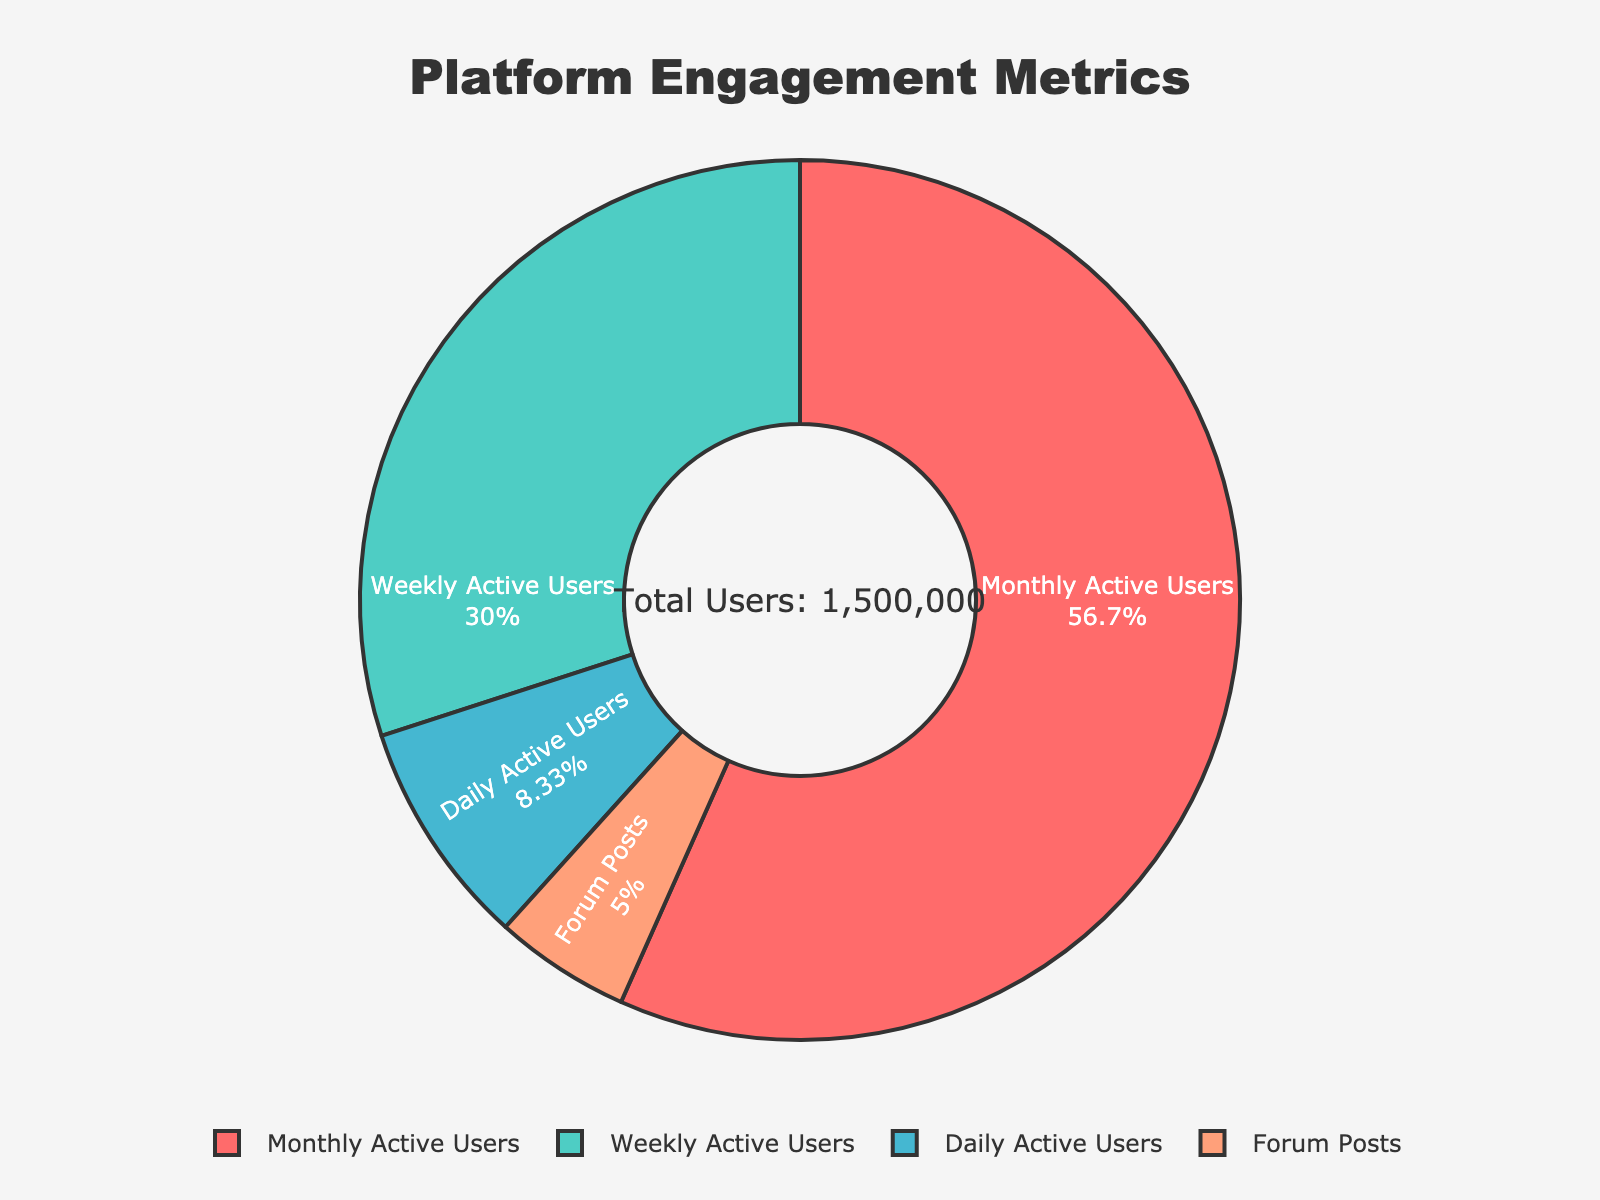What's the total number of users represented in the pie chart? The pie chart includes Daily Active Users, Weekly Active Users, and Monthly Active Users. Summing them up: 125,000 (Daily) + 450,000 (Weekly) + 850,000 (Monthly) = 1,425,000.
Answer: 1,425,000 Which metric has the largest share in the pie chart? By visually observing the largest slice in the pie chart, the Monthly Active Users have the largest share.
Answer: Monthly Active Users What percentage of the total users are Daily Active Users? The total number of users is 1,425,000. The number of Daily Active Users is 125,000. To calculate the percentage: (125,000 / 1,425,000) * 100 ≈ 8.77%.
Answer: 8.77% How does the number of Weekly Active Users compare to Daily Active Users? To compare, subtract the number of Daily Active Users from Weekly Active Users: 450,000 - 125,000 = 325,000. Hence, Weekly Active Users are 325,000 more than Daily Active Users.
Answer: 325,000 more What is the ratio of Monthly Active Users to Weekly Active Users? The number of Monthly Active Users is 850,000, and Weekly Active Users is 450,000. The ratio is 850,000:450,000, which simplifies to 17:9.
Answer: 17:9 If you sum up the percentage of Daily and Weekly Active Users, what value do you get? The percentage of Daily Active Users is 8.77% and Weekly Active Users is calculated as (450,000 / 1,425,000) * 100 ≈ 31.58%. Adding them up: 8.77% + 31.58% ≈ 40.35%.
Answer: 40.35% Considering only the values in the pie chart, which metric has the smallest value? Out of the metrics represented, the Daily Active Users have the smallest value of 125,000.
Answer: Daily Active Users 